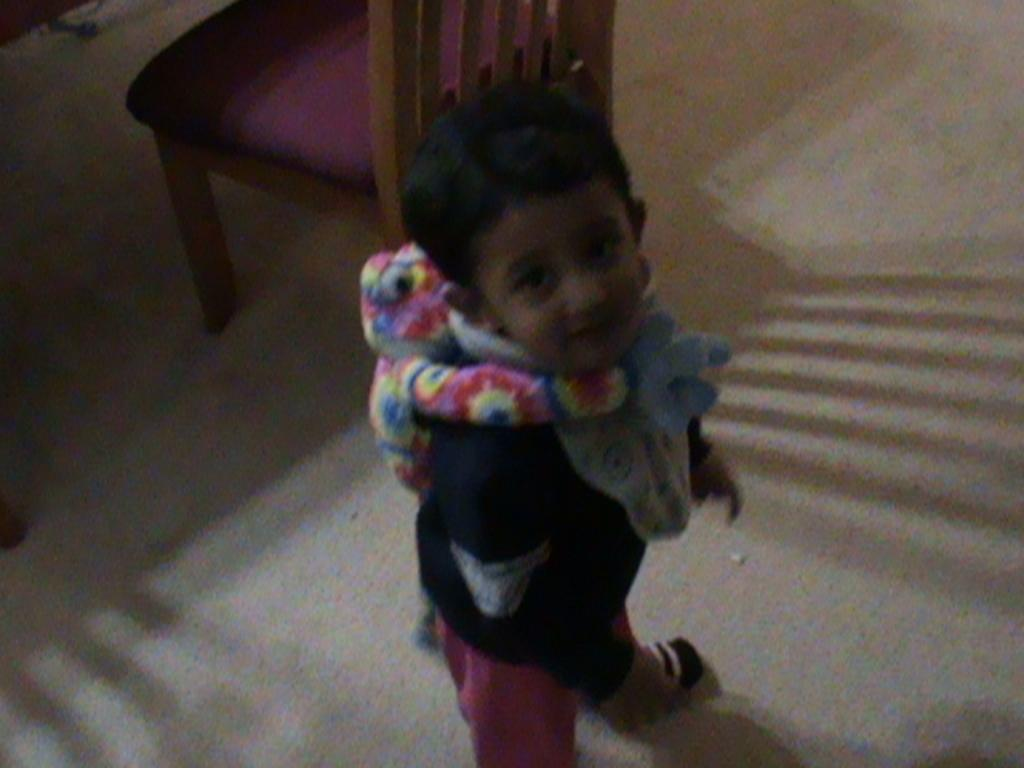Who is the main subject in the image? There is a boy in the image. What is the boy wearing? The boy is wearing a black shirt. What is the boy doing in the image? The boy is standing. What other object can be seen in the image besides the boy? There is a toy in the image, located at the boy's back. What type of furniture is present in the image? There is a chair in the image. What type of tail can be seen on the boy in the image? There is no tail present on the boy in the image. What is the kettle used for in the image? There is no kettle present in the image. 